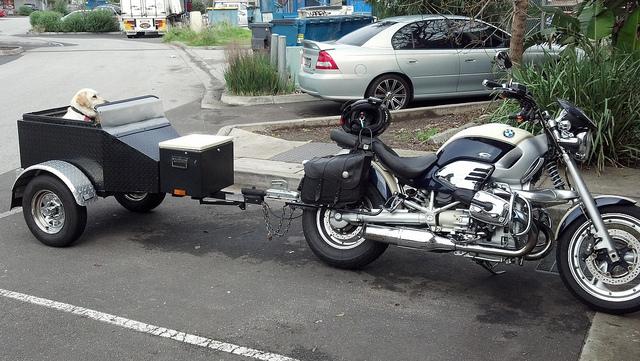What color does the car and motorcycle have in common?
Keep it brief. Silver. What is sitting in the trailer of the motorcycle?
Short answer required. Dog. Are there spokes in the wheels of the bike?
Write a very short answer. No. 